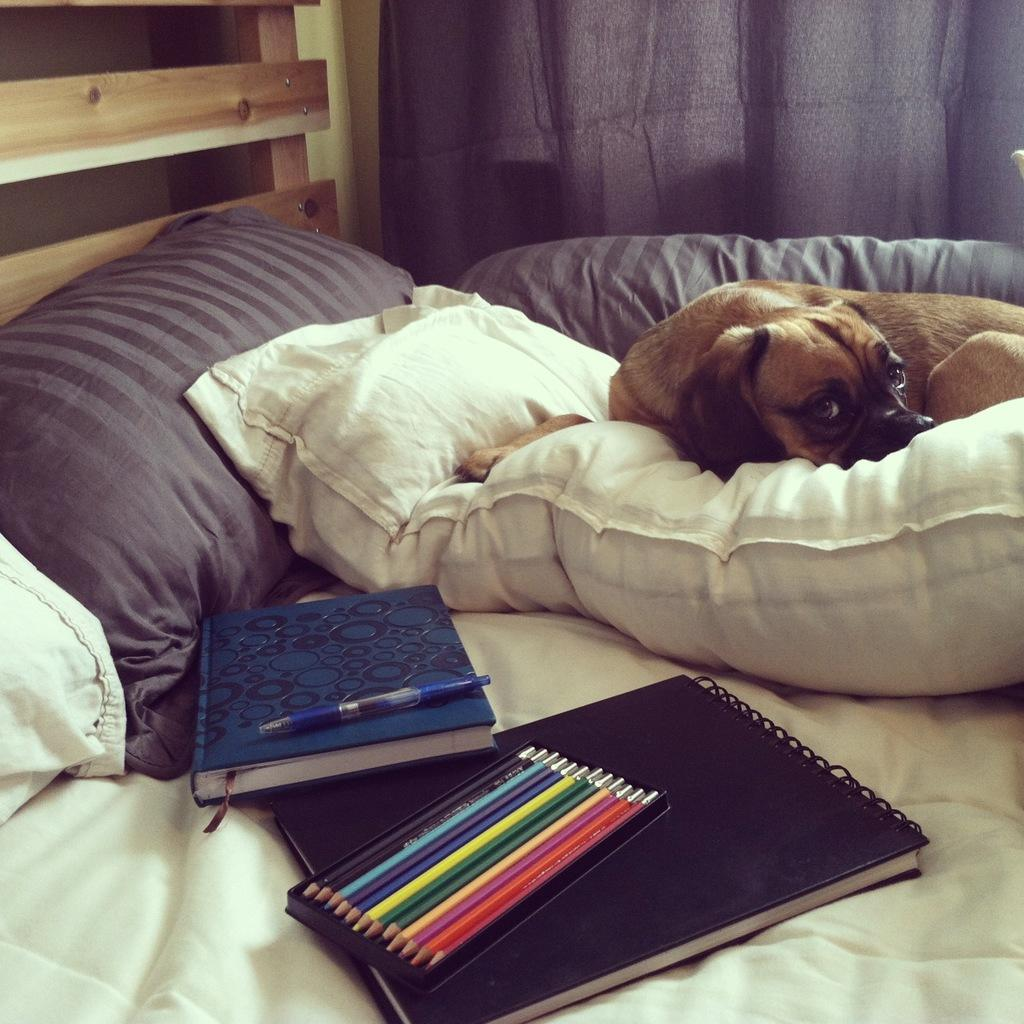What objects are on the bed in the image? There are pillows, books, pencils, and a pen on the bed. What is the dog doing in the image? The dog is on a pillow on the bed. What can be seen in the background of the image? There is a wall in the background, and a curtain is associated with it. What type of wine is being served on the island in the image? There is no wine or island present in the image; it features a bed with various objects and a dog on a pillow. 